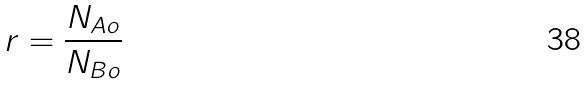<formula> <loc_0><loc_0><loc_500><loc_500>r = \frac { N _ { A o } } { N _ { B o } }</formula> 